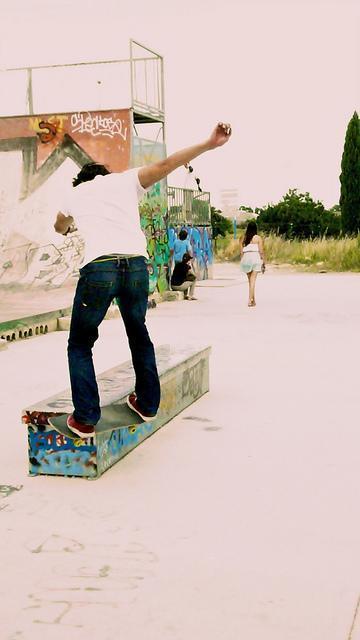How many benches are there?
Give a very brief answer. 1. 